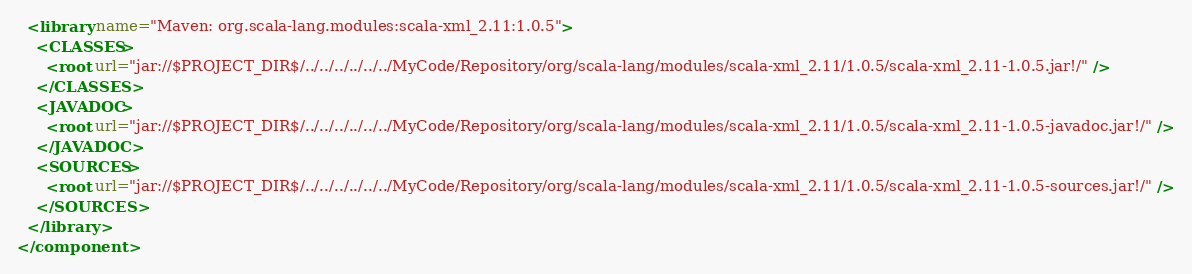Convert code to text. <code><loc_0><loc_0><loc_500><loc_500><_XML_>  <library name="Maven: org.scala-lang.modules:scala-xml_2.11:1.0.5">
    <CLASSES>
      <root url="jar://$PROJECT_DIR$/../../../../../../MyCode/Repository/org/scala-lang/modules/scala-xml_2.11/1.0.5/scala-xml_2.11-1.0.5.jar!/" />
    </CLASSES>
    <JAVADOC>
      <root url="jar://$PROJECT_DIR$/../../../../../../MyCode/Repository/org/scala-lang/modules/scala-xml_2.11/1.0.5/scala-xml_2.11-1.0.5-javadoc.jar!/" />
    </JAVADOC>
    <SOURCES>
      <root url="jar://$PROJECT_DIR$/../../../../../../MyCode/Repository/org/scala-lang/modules/scala-xml_2.11/1.0.5/scala-xml_2.11-1.0.5-sources.jar!/" />
    </SOURCES>
  </library>
</component></code> 